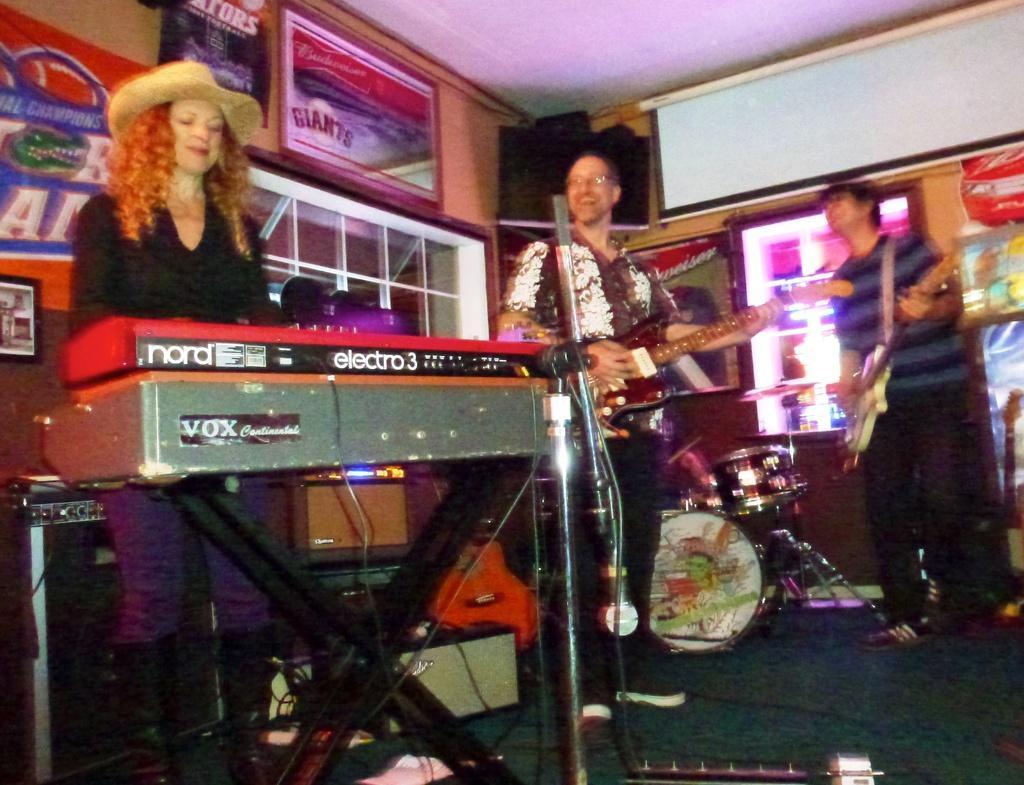Can you describe this image briefly? In the foreground of this image, there is a woman standing and playing a musical instrument. We can also see two men are playing guitars. Behind them, there are drums, frames, screen, banner, wall, ceiling, a shelf and few more objects in the background. 